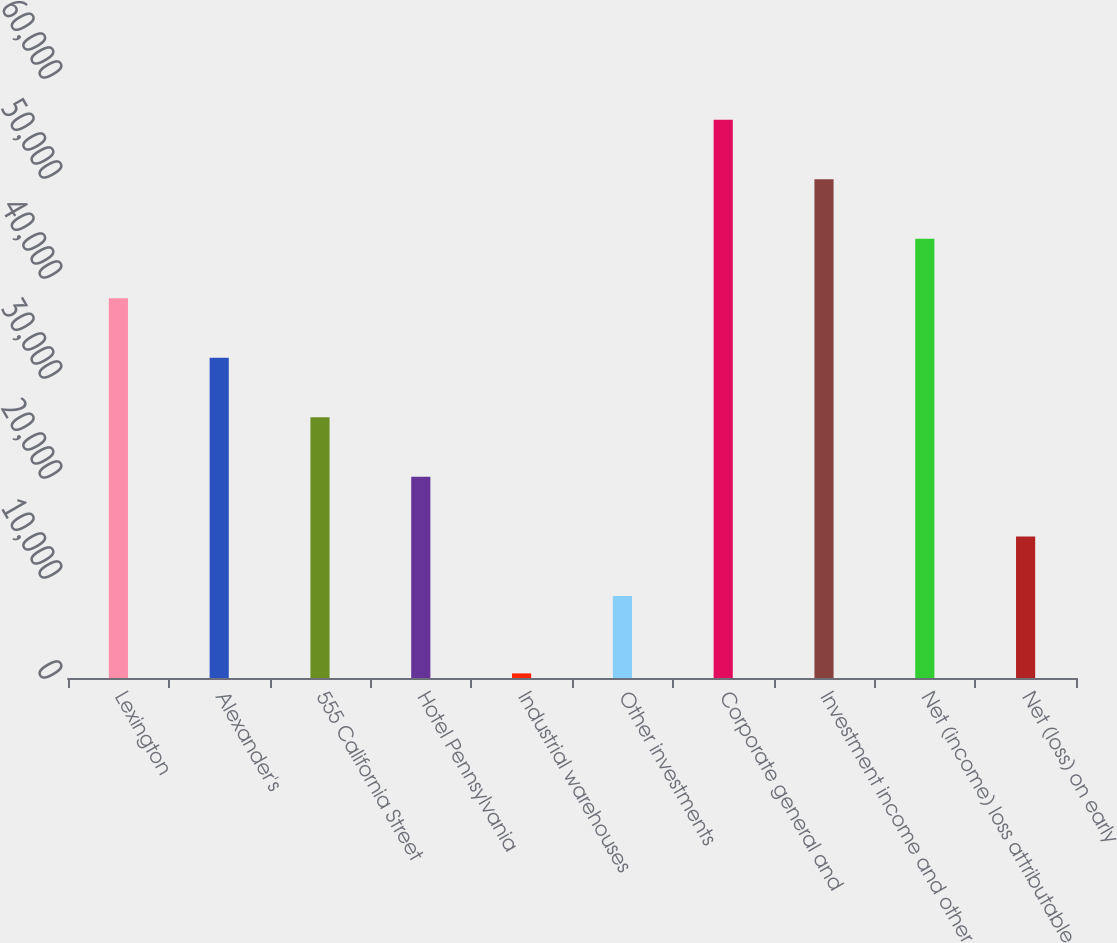Convert chart to OTSL. <chart><loc_0><loc_0><loc_500><loc_500><bar_chart><fcel>Lexington<fcel>Alexander's<fcel>555 California Street<fcel>Hotel Pennsylvania<fcel>Industrial warehouses<fcel>Other investments<fcel>Corporate general and<fcel>Investment income and other<fcel>Net (income) loss attributable<fcel>Net (loss) on early<nl><fcel>37974.5<fcel>32020.6<fcel>26066.7<fcel>20112.8<fcel>461<fcel>8205<fcel>55836.2<fcel>49882.3<fcel>43928.4<fcel>14158.9<nl></chart> 